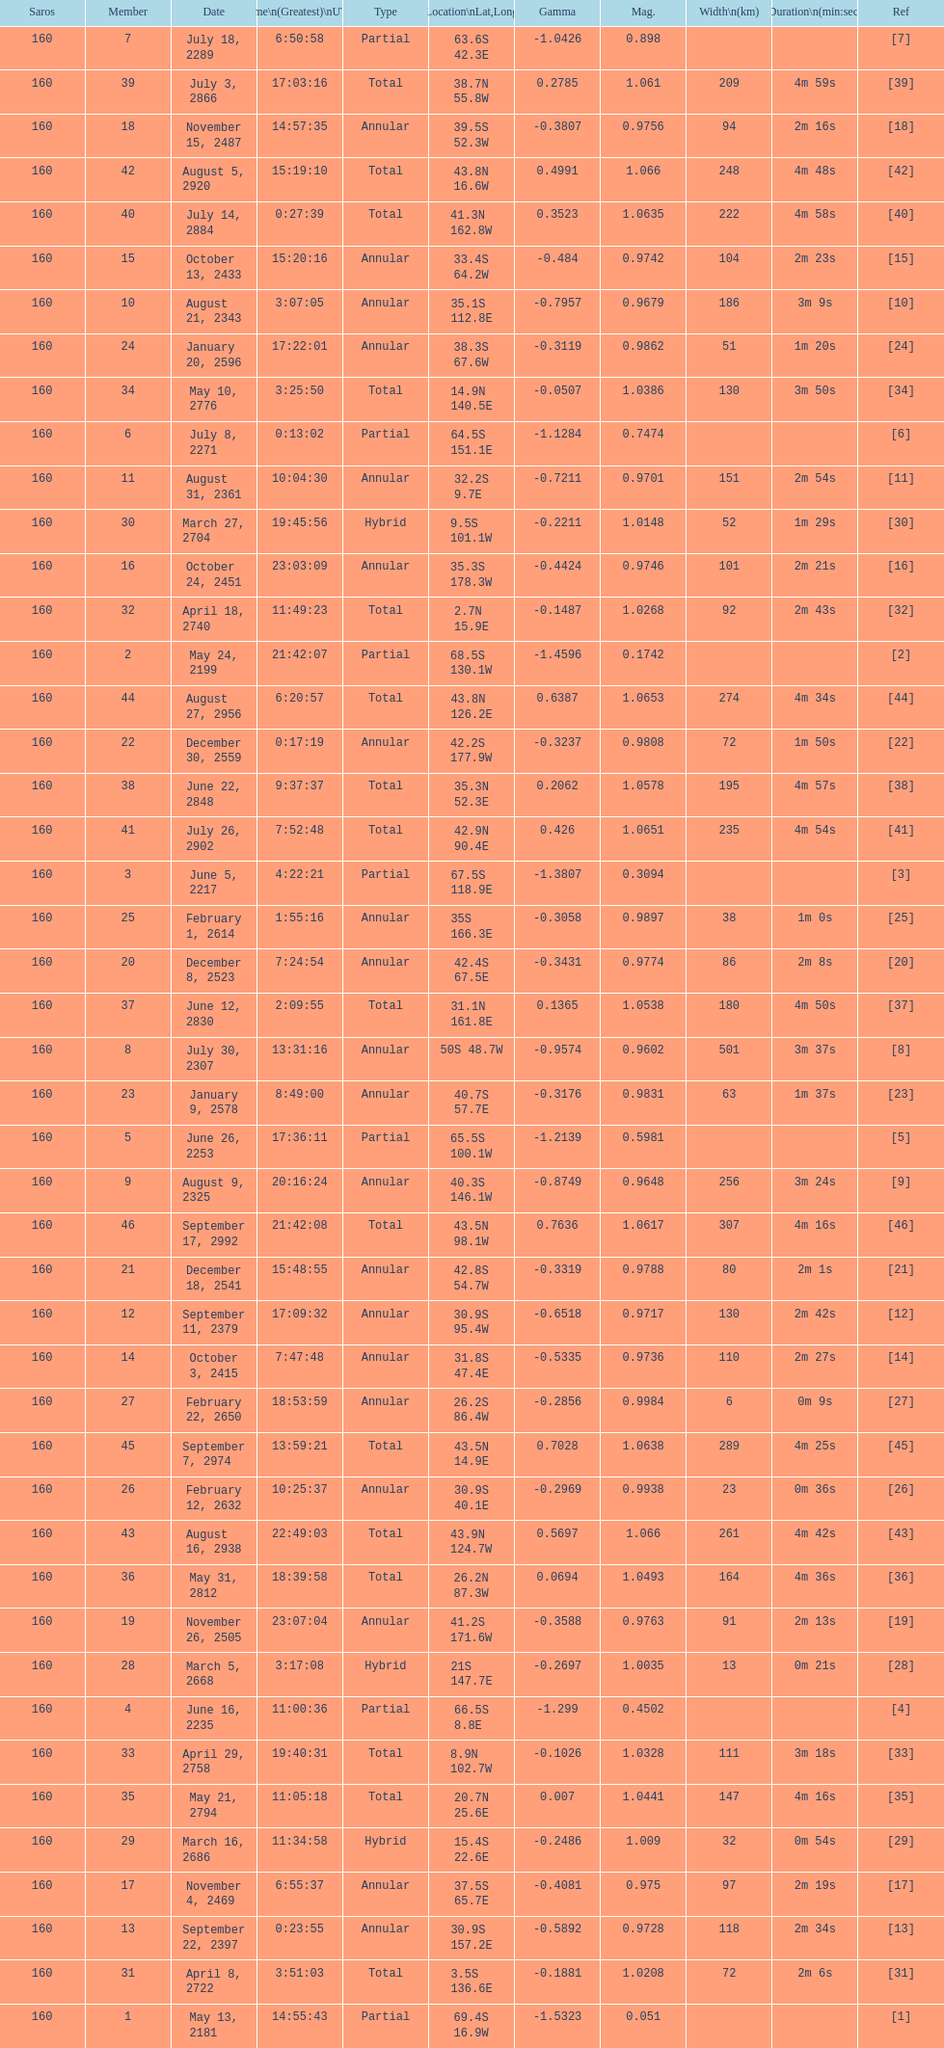Name one that has the same latitude as member number 12. 13. 